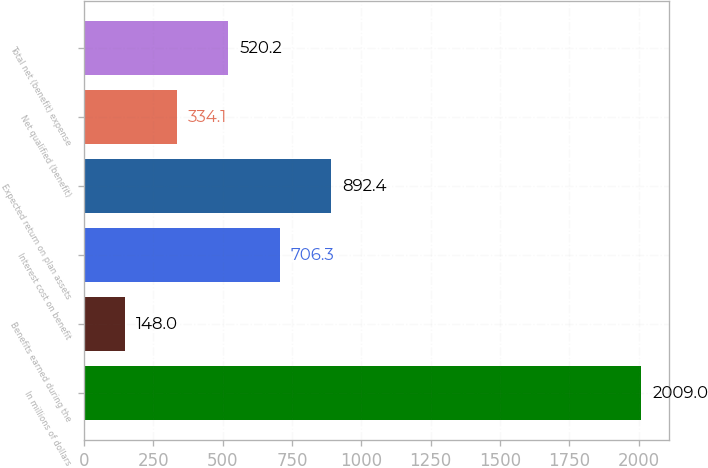<chart> <loc_0><loc_0><loc_500><loc_500><bar_chart><fcel>In millions of dollars<fcel>Benefits earned during the<fcel>Interest cost on benefit<fcel>Expected return on plan assets<fcel>Net qualified (benefit)<fcel>Total net (benefit) expense<nl><fcel>2009<fcel>148<fcel>706.3<fcel>892.4<fcel>334.1<fcel>520.2<nl></chart> 